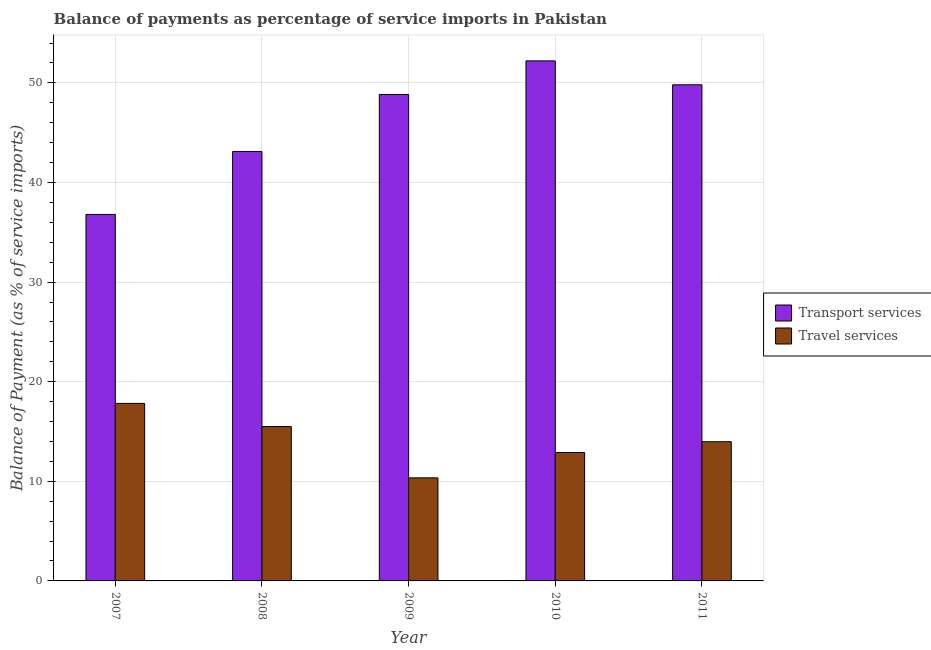How many different coloured bars are there?
Your answer should be compact. 2. How many groups of bars are there?
Make the answer very short. 5. Are the number of bars on each tick of the X-axis equal?
Your answer should be very brief. Yes. What is the balance of payments of transport services in 2008?
Provide a short and direct response. 43.11. Across all years, what is the maximum balance of payments of travel services?
Your response must be concise. 17.82. Across all years, what is the minimum balance of payments of transport services?
Offer a terse response. 36.79. What is the total balance of payments of travel services in the graph?
Offer a terse response. 70.53. What is the difference between the balance of payments of travel services in 2010 and that in 2011?
Give a very brief answer. -1.08. What is the difference between the balance of payments of transport services in 2011 and the balance of payments of travel services in 2007?
Provide a short and direct response. 13.02. What is the average balance of payments of travel services per year?
Your answer should be very brief. 14.11. What is the ratio of the balance of payments of travel services in 2008 to that in 2011?
Provide a short and direct response. 1.11. What is the difference between the highest and the second highest balance of payments of travel services?
Offer a very short reply. 2.32. What is the difference between the highest and the lowest balance of payments of travel services?
Your response must be concise. 7.47. In how many years, is the balance of payments of transport services greater than the average balance of payments of transport services taken over all years?
Your response must be concise. 3. Is the sum of the balance of payments of transport services in 2008 and 2011 greater than the maximum balance of payments of travel services across all years?
Your answer should be very brief. Yes. What does the 2nd bar from the left in 2009 represents?
Your answer should be very brief. Travel services. What does the 2nd bar from the right in 2011 represents?
Your answer should be very brief. Transport services. How many bars are there?
Offer a terse response. 10. How many years are there in the graph?
Keep it short and to the point. 5. Where does the legend appear in the graph?
Offer a very short reply. Center right. How many legend labels are there?
Make the answer very short. 2. How are the legend labels stacked?
Offer a terse response. Vertical. What is the title of the graph?
Your answer should be compact. Balance of payments as percentage of service imports in Pakistan. Does "Study and work" appear as one of the legend labels in the graph?
Your answer should be very brief. No. What is the label or title of the X-axis?
Make the answer very short. Year. What is the label or title of the Y-axis?
Your answer should be very brief. Balance of Payment (as % of service imports). What is the Balance of Payment (as % of service imports) in Transport services in 2007?
Provide a succinct answer. 36.79. What is the Balance of Payment (as % of service imports) in Travel services in 2007?
Offer a very short reply. 17.82. What is the Balance of Payment (as % of service imports) in Transport services in 2008?
Your answer should be very brief. 43.11. What is the Balance of Payment (as % of service imports) of Travel services in 2008?
Keep it short and to the point. 15.5. What is the Balance of Payment (as % of service imports) in Transport services in 2009?
Offer a terse response. 48.83. What is the Balance of Payment (as % of service imports) in Travel services in 2009?
Provide a short and direct response. 10.35. What is the Balance of Payment (as % of service imports) of Transport services in 2010?
Offer a terse response. 52.21. What is the Balance of Payment (as % of service imports) in Travel services in 2010?
Make the answer very short. 12.89. What is the Balance of Payment (as % of service imports) of Transport services in 2011?
Offer a very short reply. 49.81. What is the Balance of Payment (as % of service imports) in Travel services in 2011?
Provide a short and direct response. 13.97. Across all years, what is the maximum Balance of Payment (as % of service imports) of Transport services?
Your answer should be very brief. 52.21. Across all years, what is the maximum Balance of Payment (as % of service imports) of Travel services?
Ensure brevity in your answer.  17.82. Across all years, what is the minimum Balance of Payment (as % of service imports) of Transport services?
Provide a short and direct response. 36.79. Across all years, what is the minimum Balance of Payment (as % of service imports) in Travel services?
Ensure brevity in your answer.  10.35. What is the total Balance of Payment (as % of service imports) of Transport services in the graph?
Your answer should be compact. 230.76. What is the total Balance of Payment (as % of service imports) of Travel services in the graph?
Offer a very short reply. 70.53. What is the difference between the Balance of Payment (as % of service imports) of Transport services in 2007 and that in 2008?
Provide a short and direct response. -6.32. What is the difference between the Balance of Payment (as % of service imports) of Travel services in 2007 and that in 2008?
Offer a terse response. 2.32. What is the difference between the Balance of Payment (as % of service imports) in Transport services in 2007 and that in 2009?
Provide a succinct answer. -12.04. What is the difference between the Balance of Payment (as % of service imports) in Travel services in 2007 and that in 2009?
Ensure brevity in your answer.  7.47. What is the difference between the Balance of Payment (as % of service imports) of Transport services in 2007 and that in 2010?
Provide a succinct answer. -15.42. What is the difference between the Balance of Payment (as % of service imports) of Travel services in 2007 and that in 2010?
Provide a succinct answer. 4.93. What is the difference between the Balance of Payment (as % of service imports) of Transport services in 2007 and that in 2011?
Ensure brevity in your answer.  -13.02. What is the difference between the Balance of Payment (as % of service imports) in Travel services in 2007 and that in 2011?
Keep it short and to the point. 3.85. What is the difference between the Balance of Payment (as % of service imports) of Transport services in 2008 and that in 2009?
Offer a very short reply. -5.72. What is the difference between the Balance of Payment (as % of service imports) in Travel services in 2008 and that in 2009?
Make the answer very short. 5.15. What is the difference between the Balance of Payment (as % of service imports) of Transport services in 2008 and that in 2010?
Provide a short and direct response. -9.1. What is the difference between the Balance of Payment (as % of service imports) in Travel services in 2008 and that in 2010?
Give a very brief answer. 2.61. What is the difference between the Balance of Payment (as % of service imports) of Transport services in 2008 and that in 2011?
Offer a very short reply. -6.69. What is the difference between the Balance of Payment (as % of service imports) in Travel services in 2008 and that in 2011?
Your answer should be compact. 1.52. What is the difference between the Balance of Payment (as % of service imports) of Transport services in 2009 and that in 2010?
Your response must be concise. -3.38. What is the difference between the Balance of Payment (as % of service imports) of Travel services in 2009 and that in 2010?
Ensure brevity in your answer.  -2.55. What is the difference between the Balance of Payment (as % of service imports) of Transport services in 2009 and that in 2011?
Your answer should be compact. -0.98. What is the difference between the Balance of Payment (as % of service imports) in Travel services in 2009 and that in 2011?
Your answer should be compact. -3.63. What is the difference between the Balance of Payment (as % of service imports) in Transport services in 2010 and that in 2011?
Your response must be concise. 2.4. What is the difference between the Balance of Payment (as % of service imports) in Travel services in 2010 and that in 2011?
Your answer should be very brief. -1.08. What is the difference between the Balance of Payment (as % of service imports) in Transport services in 2007 and the Balance of Payment (as % of service imports) in Travel services in 2008?
Your answer should be very brief. 21.29. What is the difference between the Balance of Payment (as % of service imports) in Transport services in 2007 and the Balance of Payment (as % of service imports) in Travel services in 2009?
Your answer should be very brief. 26.44. What is the difference between the Balance of Payment (as % of service imports) in Transport services in 2007 and the Balance of Payment (as % of service imports) in Travel services in 2010?
Your answer should be compact. 23.9. What is the difference between the Balance of Payment (as % of service imports) of Transport services in 2007 and the Balance of Payment (as % of service imports) of Travel services in 2011?
Provide a succinct answer. 22.82. What is the difference between the Balance of Payment (as % of service imports) in Transport services in 2008 and the Balance of Payment (as % of service imports) in Travel services in 2009?
Your response must be concise. 32.77. What is the difference between the Balance of Payment (as % of service imports) in Transport services in 2008 and the Balance of Payment (as % of service imports) in Travel services in 2010?
Make the answer very short. 30.22. What is the difference between the Balance of Payment (as % of service imports) in Transport services in 2008 and the Balance of Payment (as % of service imports) in Travel services in 2011?
Give a very brief answer. 29.14. What is the difference between the Balance of Payment (as % of service imports) in Transport services in 2009 and the Balance of Payment (as % of service imports) in Travel services in 2010?
Offer a very short reply. 35.94. What is the difference between the Balance of Payment (as % of service imports) in Transport services in 2009 and the Balance of Payment (as % of service imports) in Travel services in 2011?
Offer a very short reply. 34.86. What is the difference between the Balance of Payment (as % of service imports) of Transport services in 2010 and the Balance of Payment (as % of service imports) of Travel services in 2011?
Your response must be concise. 38.23. What is the average Balance of Payment (as % of service imports) of Transport services per year?
Give a very brief answer. 46.15. What is the average Balance of Payment (as % of service imports) in Travel services per year?
Ensure brevity in your answer.  14.11. In the year 2007, what is the difference between the Balance of Payment (as % of service imports) of Transport services and Balance of Payment (as % of service imports) of Travel services?
Your answer should be very brief. 18.97. In the year 2008, what is the difference between the Balance of Payment (as % of service imports) of Transport services and Balance of Payment (as % of service imports) of Travel services?
Make the answer very short. 27.62. In the year 2009, what is the difference between the Balance of Payment (as % of service imports) in Transport services and Balance of Payment (as % of service imports) in Travel services?
Provide a succinct answer. 38.49. In the year 2010, what is the difference between the Balance of Payment (as % of service imports) of Transport services and Balance of Payment (as % of service imports) of Travel services?
Your answer should be very brief. 39.32. In the year 2011, what is the difference between the Balance of Payment (as % of service imports) of Transport services and Balance of Payment (as % of service imports) of Travel services?
Keep it short and to the point. 35.83. What is the ratio of the Balance of Payment (as % of service imports) of Transport services in 2007 to that in 2008?
Your response must be concise. 0.85. What is the ratio of the Balance of Payment (as % of service imports) of Travel services in 2007 to that in 2008?
Make the answer very short. 1.15. What is the ratio of the Balance of Payment (as % of service imports) in Transport services in 2007 to that in 2009?
Ensure brevity in your answer.  0.75. What is the ratio of the Balance of Payment (as % of service imports) in Travel services in 2007 to that in 2009?
Ensure brevity in your answer.  1.72. What is the ratio of the Balance of Payment (as % of service imports) of Transport services in 2007 to that in 2010?
Keep it short and to the point. 0.7. What is the ratio of the Balance of Payment (as % of service imports) in Travel services in 2007 to that in 2010?
Ensure brevity in your answer.  1.38. What is the ratio of the Balance of Payment (as % of service imports) in Transport services in 2007 to that in 2011?
Keep it short and to the point. 0.74. What is the ratio of the Balance of Payment (as % of service imports) of Travel services in 2007 to that in 2011?
Provide a succinct answer. 1.28. What is the ratio of the Balance of Payment (as % of service imports) of Transport services in 2008 to that in 2009?
Provide a succinct answer. 0.88. What is the ratio of the Balance of Payment (as % of service imports) of Travel services in 2008 to that in 2009?
Give a very brief answer. 1.5. What is the ratio of the Balance of Payment (as % of service imports) in Transport services in 2008 to that in 2010?
Provide a short and direct response. 0.83. What is the ratio of the Balance of Payment (as % of service imports) in Travel services in 2008 to that in 2010?
Offer a terse response. 1.2. What is the ratio of the Balance of Payment (as % of service imports) in Transport services in 2008 to that in 2011?
Provide a succinct answer. 0.87. What is the ratio of the Balance of Payment (as % of service imports) in Travel services in 2008 to that in 2011?
Make the answer very short. 1.11. What is the ratio of the Balance of Payment (as % of service imports) in Transport services in 2009 to that in 2010?
Provide a succinct answer. 0.94. What is the ratio of the Balance of Payment (as % of service imports) of Travel services in 2009 to that in 2010?
Offer a very short reply. 0.8. What is the ratio of the Balance of Payment (as % of service imports) in Transport services in 2009 to that in 2011?
Your answer should be compact. 0.98. What is the ratio of the Balance of Payment (as % of service imports) in Travel services in 2009 to that in 2011?
Your answer should be very brief. 0.74. What is the ratio of the Balance of Payment (as % of service imports) of Transport services in 2010 to that in 2011?
Provide a succinct answer. 1.05. What is the ratio of the Balance of Payment (as % of service imports) in Travel services in 2010 to that in 2011?
Keep it short and to the point. 0.92. What is the difference between the highest and the second highest Balance of Payment (as % of service imports) in Transport services?
Your answer should be compact. 2.4. What is the difference between the highest and the second highest Balance of Payment (as % of service imports) of Travel services?
Your answer should be compact. 2.32. What is the difference between the highest and the lowest Balance of Payment (as % of service imports) of Transport services?
Provide a succinct answer. 15.42. What is the difference between the highest and the lowest Balance of Payment (as % of service imports) of Travel services?
Ensure brevity in your answer.  7.47. 